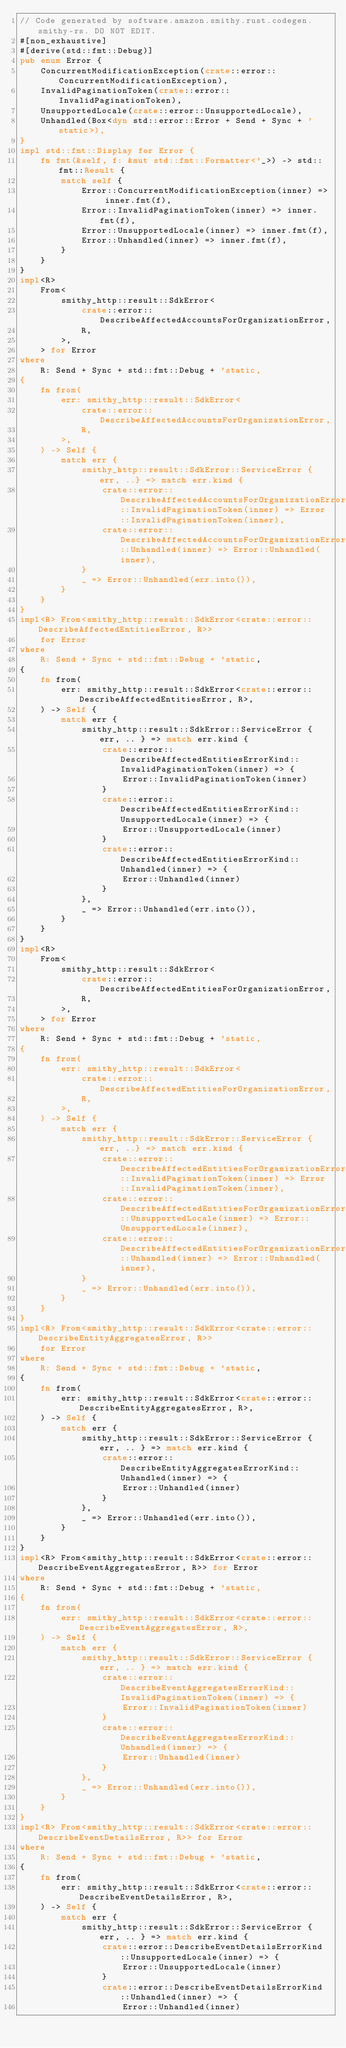<code> <loc_0><loc_0><loc_500><loc_500><_Rust_>// Code generated by software.amazon.smithy.rust.codegen.smithy-rs. DO NOT EDIT.
#[non_exhaustive]
#[derive(std::fmt::Debug)]
pub enum Error {
    ConcurrentModificationException(crate::error::ConcurrentModificationException),
    InvalidPaginationToken(crate::error::InvalidPaginationToken),
    UnsupportedLocale(crate::error::UnsupportedLocale),
    Unhandled(Box<dyn std::error::Error + Send + Sync + 'static>),
}
impl std::fmt::Display for Error {
    fn fmt(&self, f: &mut std::fmt::Formatter<'_>) -> std::fmt::Result {
        match self {
            Error::ConcurrentModificationException(inner) => inner.fmt(f),
            Error::InvalidPaginationToken(inner) => inner.fmt(f),
            Error::UnsupportedLocale(inner) => inner.fmt(f),
            Error::Unhandled(inner) => inner.fmt(f),
        }
    }
}
impl<R>
    From<
        smithy_http::result::SdkError<
            crate::error::DescribeAffectedAccountsForOrganizationError,
            R,
        >,
    > for Error
where
    R: Send + Sync + std::fmt::Debug + 'static,
{
    fn from(
        err: smithy_http::result::SdkError<
            crate::error::DescribeAffectedAccountsForOrganizationError,
            R,
        >,
    ) -> Self {
        match err {
            smithy_http::result::SdkError::ServiceError { err, ..} => match err.kind {
                crate::error::DescribeAffectedAccountsForOrganizationErrorKind::InvalidPaginationToken(inner) => Error::InvalidPaginationToken(inner),
                crate::error::DescribeAffectedAccountsForOrganizationErrorKind::Unhandled(inner) => Error::Unhandled(inner),
            }
            _ => Error::Unhandled(err.into()),
        }
    }
}
impl<R> From<smithy_http::result::SdkError<crate::error::DescribeAffectedEntitiesError, R>>
    for Error
where
    R: Send + Sync + std::fmt::Debug + 'static,
{
    fn from(
        err: smithy_http::result::SdkError<crate::error::DescribeAffectedEntitiesError, R>,
    ) -> Self {
        match err {
            smithy_http::result::SdkError::ServiceError { err, .. } => match err.kind {
                crate::error::DescribeAffectedEntitiesErrorKind::InvalidPaginationToken(inner) => {
                    Error::InvalidPaginationToken(inner)
                }
                crate::error::DescribeAffectedEntitiesErrorKind::UnsupportedLocale(inner) => {
                    Error::UnsupportedLocale(inner)
                }
                crate::error::DescribeAffectedEntitiesErrorKind::Unhandled(inner) => {
                    Error::Unhandled(inner)
                }
            },
            _ => Error::Unhandled(err.into()),
        }
    }
}
impl<R>
    From<
        smithy_http::result::SdkError<
            crate::error::DescribeAffectedEntitiesForOrganizationError,
            R,
        >,
    > for Error
where
    R: Send + Sync + std::fmt::Debug + 'static,
{
    fn from(
        err: smithy_http::result::SdkError<
            crate::error::DescribeAffectedEntitiesForOrganizationError,
            R,
        >,
    ) -> Self {
        match err {
            smithy_http::result::SdkError::ServiceError { err, ..} => match err.kind {
                crate::error::DescribeAffectedEntitiesForOrganizationErrorKind::InvalidPaginationToken(inner) => Error::InvalidPaginationToken(inner),
                crate::error::DescribeAffectedEntitiesForOrganizationErrorKind::UnsupportedLocale(inner) => Error::UnsupportedLocale(inner),
                crate::error::DescribeAffectedEntitiesForOrganizationErrorKind::Unhandled(inner) => Error::Unhandled(inner),
            }
            _ => Error::Unhandled(err.into()),
        }
    }
}
impl<R> From<smithy_http::result::SdkError<crate::error::DescribeEntityAggregatesError, R>>
    for Error
where
    R: Send + Sync + std::fmt::Debug + 'static,
{
    fn from(
        err: smithy_http::result::SdkError<crate::error::DescribeEntityAggregatesError, R>,
    ) -> Self {
        match err {
            smithy_http::result::SdkError::ServiceError { err, .. } => match err.kind {
                crate::error::DescribeEntityAggregatesErrorKind::Unhandled(inner) => {
                    Error::Unhandled(inner)
                }
            },
            _ => Error::Unhandled(err.into()),
        }
    }
}
impl<R> From<smithy_http::result::SdkError<crate::error::DescribeEventAggregatesError, R>> for Error
where
    R: Send + Sync + std::fmt::Debug + 'static,
{
    fn from(
        err: smithy_http::result::SdkError<crate::error::DescribeEventAggregatesError, R>,
    ) -> Self {
        match err {
            smithy_http::result::SdkError::ServiceError { err, .. } => match err.kind {
                crate::error::DescribeEventAggregatesErrorKind::InvalidPaginationToken(inner) => {
                    Error::InvalidPaginationToken(inner)
                }
                crate::error::DescribeEventAggregatesErrorKind::Unhandled(inner) => {
                    Error::Unhandled(inner)
                }
            },
            _ => Error::Unhandled(err.into()),
        }
    }
}
impl<R> From<smithy_http::result::SdkError<crate::error::DescribeEventDetailsError, R>> for Error
where
    R: Send + Sync + std::fmt::Debug + 'static,
{
    fn from(
        err: smithy_http::result::SdkError<crate::error::DescribeEventDetailsError, R>,
    ) -> Self {
        match err {
            smithy_http::result::SdkError::ServiceError { err, .. } => match err.kind {
                crate::error::DescribeEventDetailsErrorKind::UnsupportedLocale(inner) => {
                    Error::UnsupportedLocale(inner)
                }
                crate::error::DescribeEventDetailsErrorKind::Unhandled(inner) => {
                    Error::Unhandled(inner)</code> 